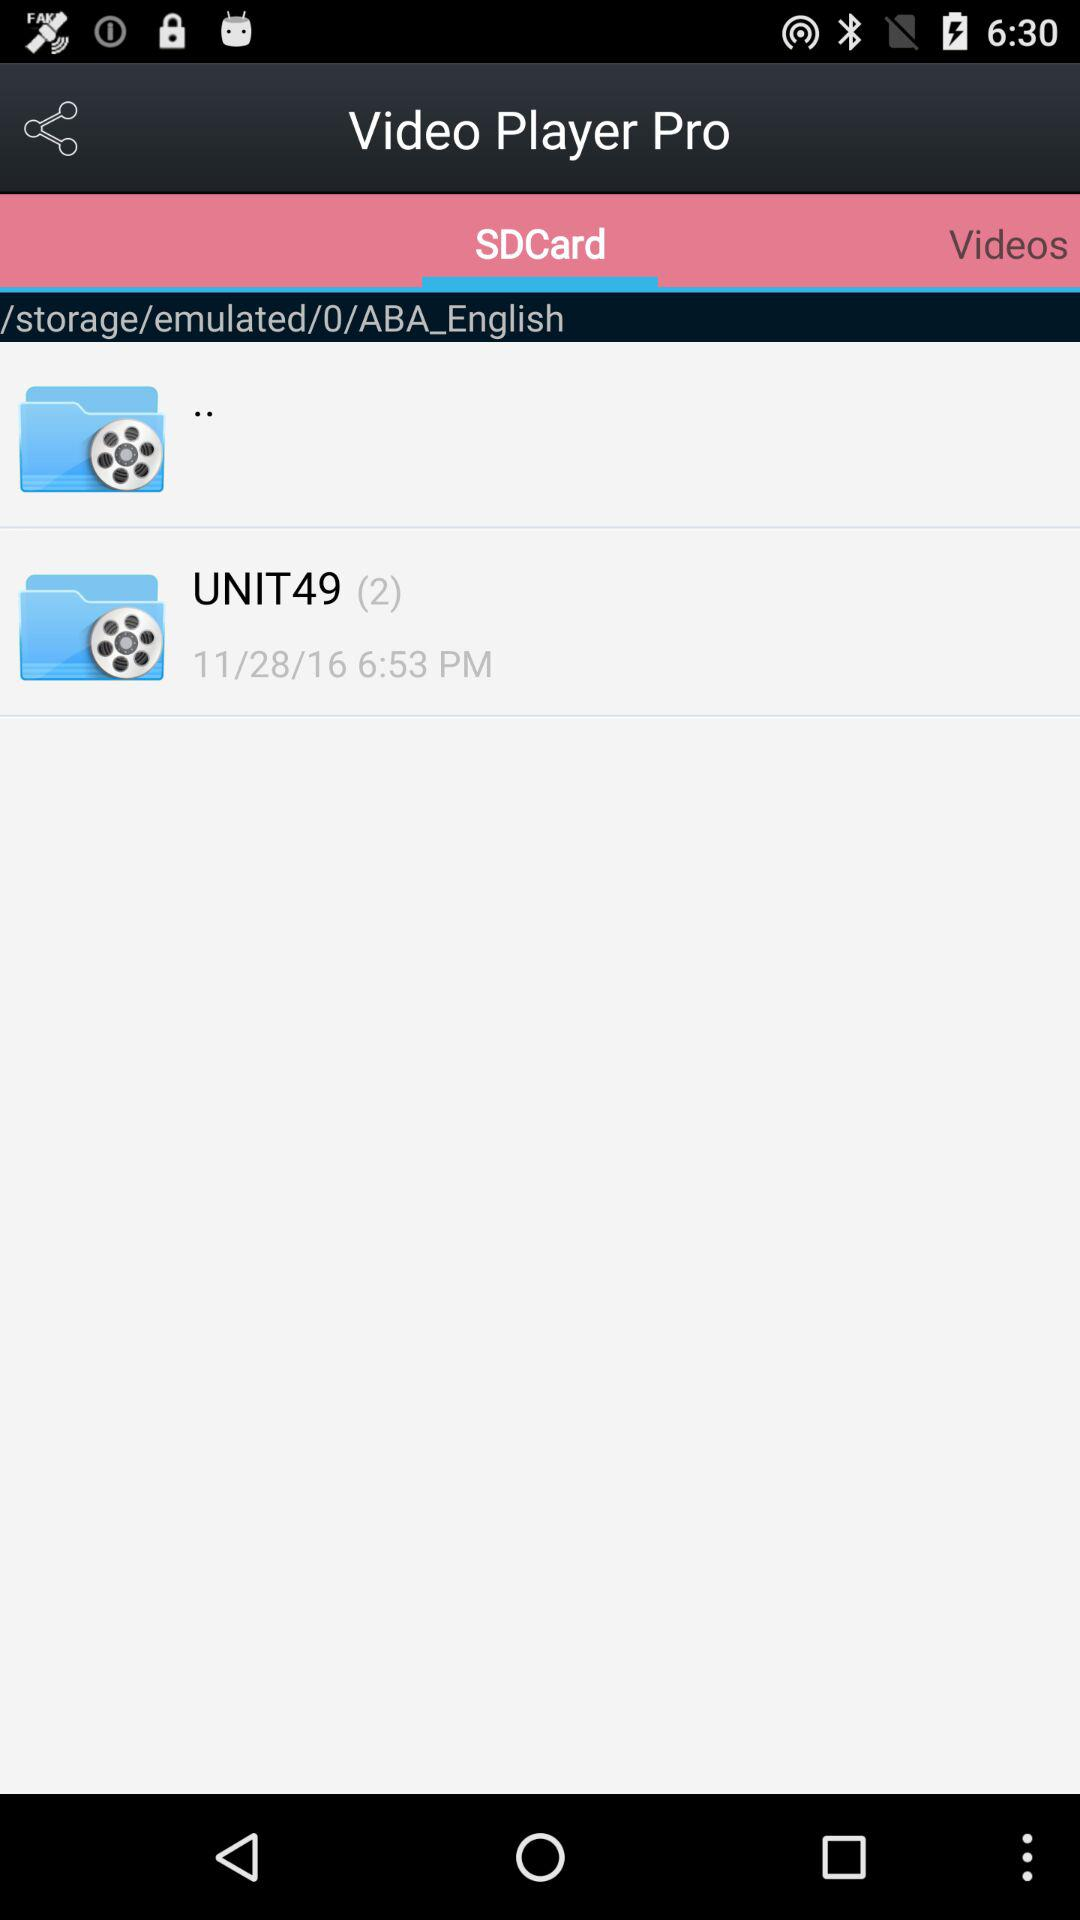How many videos are in the folder UNIT49?
Answer the question using a single word or phrase. 2 